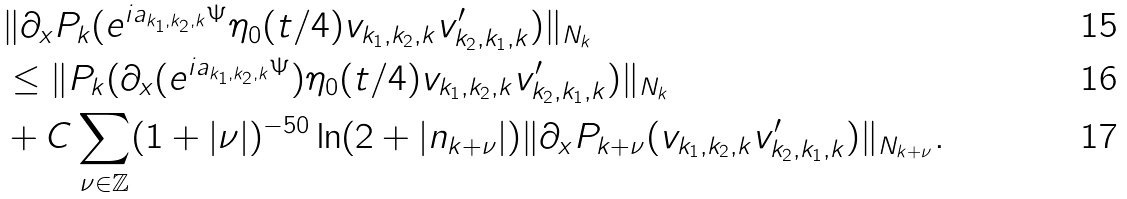<formula> <loc_0><loc_0><loc_500><loc_500>& \| \partial _ { x } P _ { k } ( e ^ { i a _ { k _ { 1 } , k _ { 2 } , k } \Psi } \eta _ { 0 } ( t / 4 ) v _ { k _ { 1 } , k _ { 2 } , k } v ^ { \prime } _ { k _ { 2 } , k _ { 1 } , k } ) \| _ { N _ { k } } \\ & \leq \| P _ { k } ( \partial _ { x } ( e ^ { i a _ { k _ { 1 } , k _ { 2 } , k } \Psi } ) \eta _ { 0 } ( t / 4 ) v _ { k _ { 1 } , k _ { 2 } , k } v ^ { \prime } _ { k _ { 2 } , k _ { 1 } , k } ) \| _ { N _ { k } } \\ & + C \sum _ { \nu \in \mathbb { Z } } ( 1 + | \nu | ) ^ { - 5 0 } \ln ( 2 + | n _ { k + \nu } | ) \| \partial _ { x } P _ { k + \nu } ( v _ { k _ { 1 } , k _ { 2 } , k } v ^ { \prime } _ { k _ { 2 } , k _ { 1 } , k } ) \| _ { N _ { k + \nu } } .</formula> 